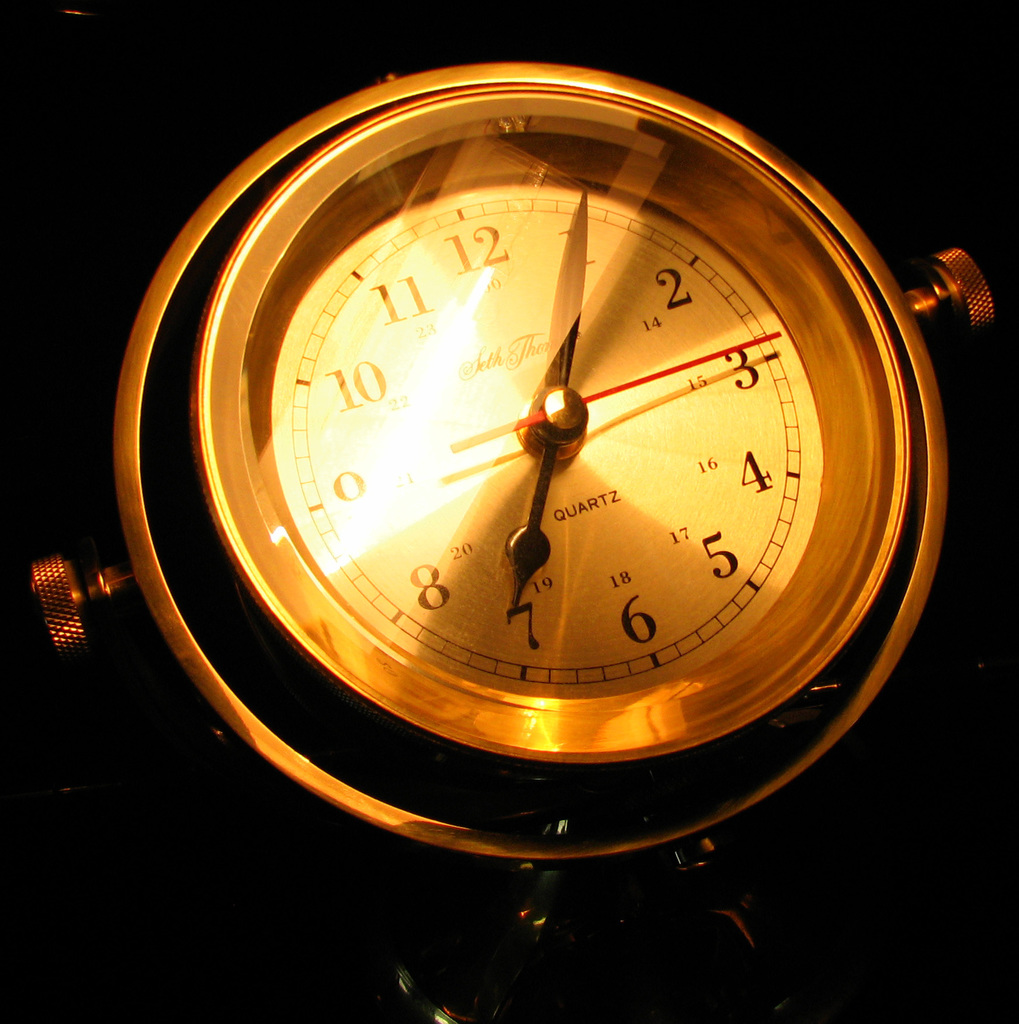Can you infer the setting or environment where this clock might be located based on its style? Given its elegant design and the soft, focused lighting, the clock is likely hung in a formal setting, such as a stately home or an office, where the importance of both form and function is emphasized.  What does the clock's design say about its possible era of manufacture? The design of the clock, with its Roman numerals and the simplicity of the dial, suggests a nod to classic aesthetics possibly originating from the mid-20th century, a time when such timeless elegance was coveted. 